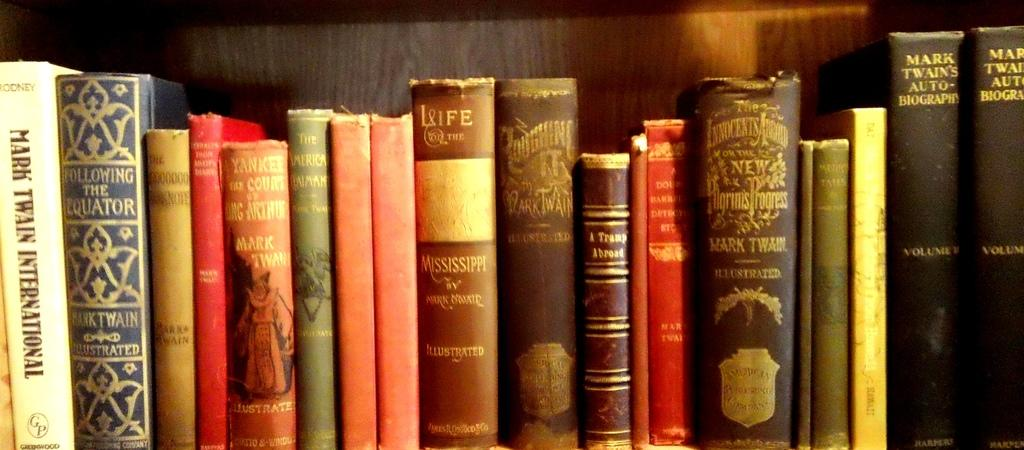<image>
Share a concise interpretation of the image provided. A collection of vintage books including Mark Twain International on the far left 